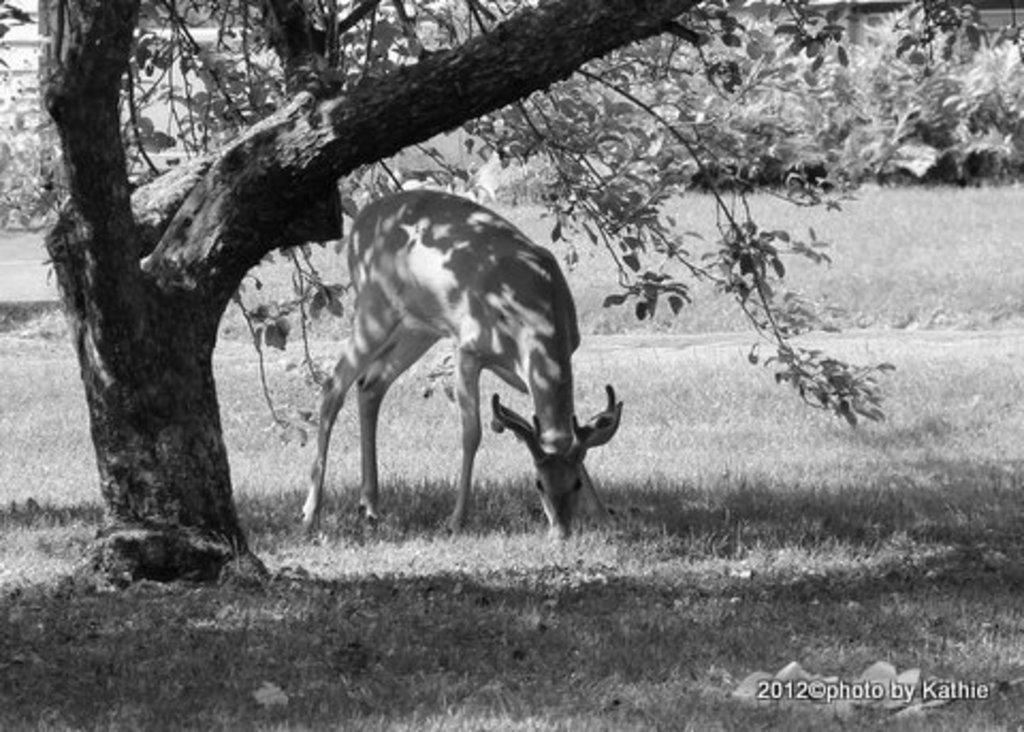What type of creature is in the image? There is an animal in the image. Where is the animal located in the image? The animal is under a tree. What is the color scheme of the image? The image is black and white. What type of vegetation is on the ground in the image? There is grass on the ground in the image. What type of glove is hanging from the tree in the image? There is no glove present in the image; it features an animal under a tree. Can you tell me how many seeds are visible on the ground in the image? There is no mention of seeds in the image; it only features an animal, a tree, and grass on the ground. 